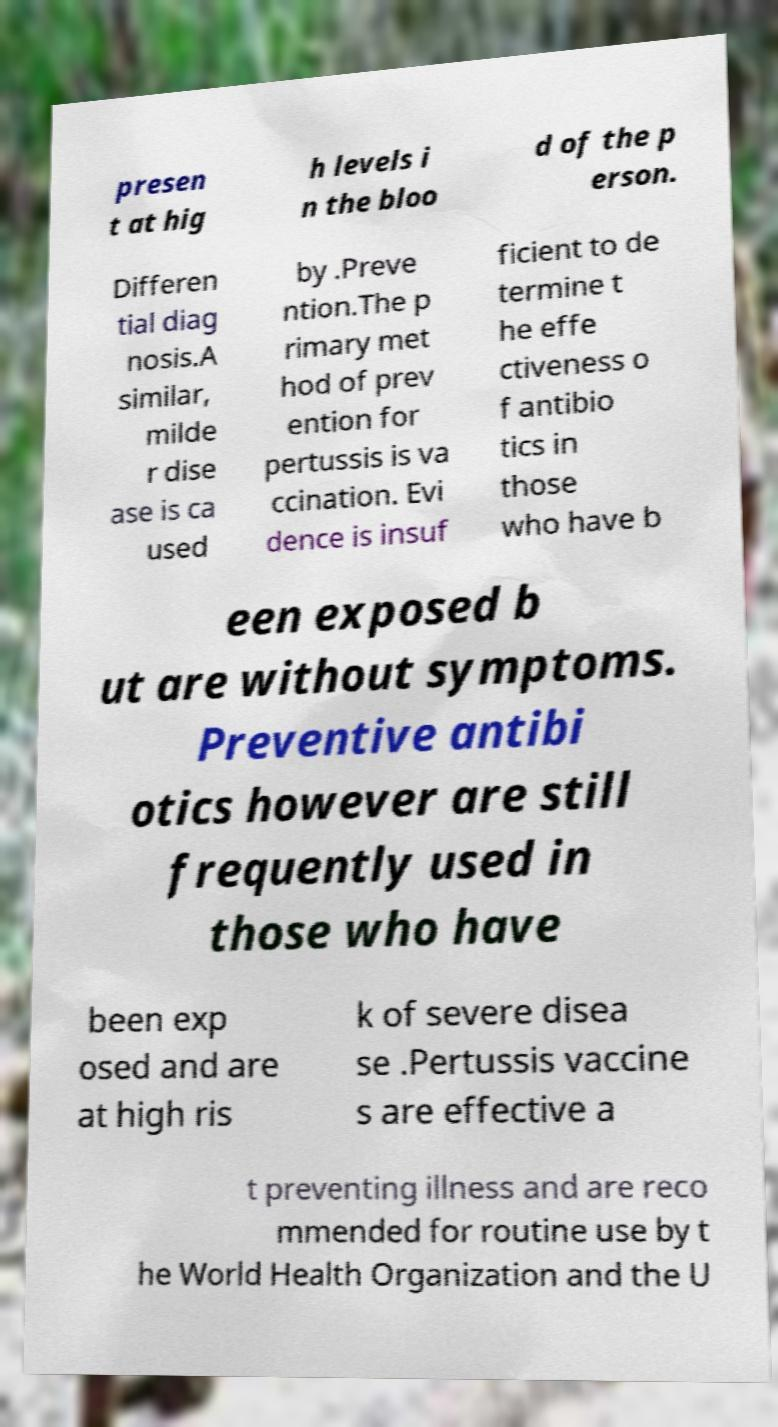Could you extract and type out the text from this image? presen t at hig h levels i n the bloo d of the p erson. Differen tial diag nosis.A similar, milde r dise ase is ca used by .Preve ntion.The p rimary met hod of prev ention for pertussis is va ccination. Evi dence is insuf ficient to de termine t he effe ctiveness o f antibio tics in those who have b een exposed b ut are without symptoms. Preventive antibi otics however are still frequently used in those who have been exp osed and are at high ris k of severe disea se .Pertussis vaccine s are effective a t preventing illness and are reco mmended for routine use by t he World Health Organization and the U 